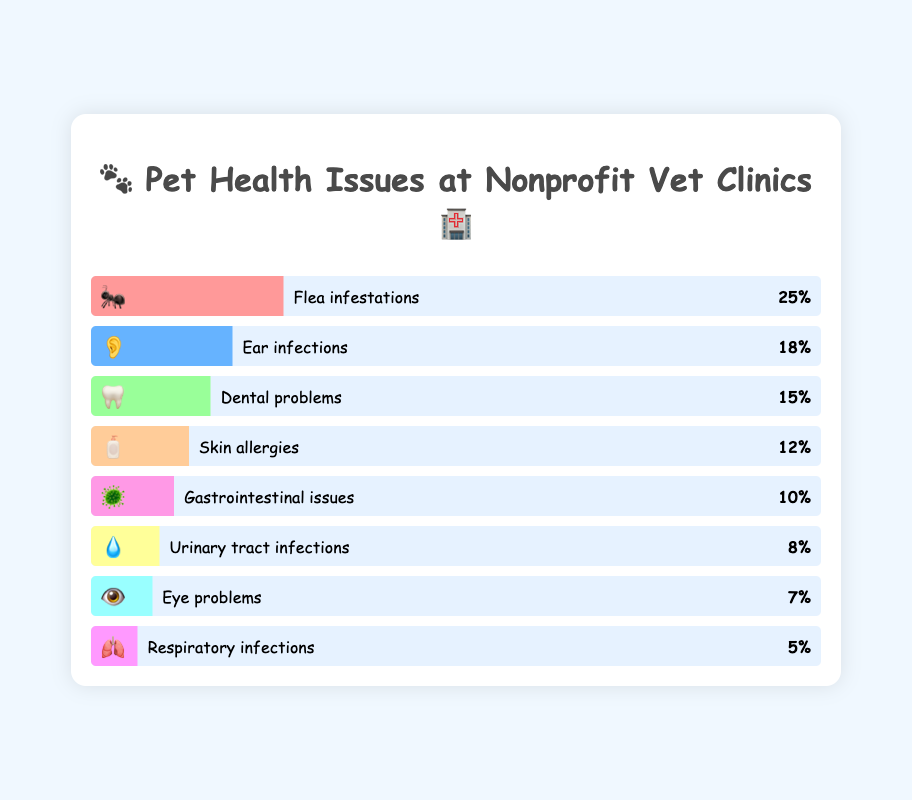What's the most common pet health issue treated at nonprofit veterinary clinics? The figure shows a bar chart with different health issues represented by percentages. The largest bar, representing the highest percentage, corresponds to flea infestations.
Answer: Flea infestations Which pet health issue has a higher percentage, dental problems or gastrointestinal issues? By comparing the lengths of the bars, the dental problems bar (15%) is longer than the gastrointestinal issues bar (10%).
Answer: Dental problems How much greater is the percentage of ear infections compared to urinary tract infections? Ear infections are at 18%, and urinary tract infections are at 8%. The difference is calculated by subtracting 8 from 18.
Answer: 10% What percentage of pet health issues are related to skin allergies and gastrointestinal issues combined? To find the combined percentage, add the percentages of skin allergies (12%) and gastrointestinal issues (10%).
Answer: 22% Which health issue has the smallest percentage, and what is that percentage? The shortest bar corresponds to respiratory infections, which is 5%.
Answer: Respiratory infections, 5% Compare the percentage of eye problems to the percentage of urinary tract infections. Which one is higher? The eye problems percentage is 7%, and the urinary tract infections percentage is 8%. Comparing these, urinary tract infections have a higher percentage.
Answer: Urinary tract infections What's the combined percentage of the three least common pet health issues? The least common issues are respiratory infections (5%), eye problems (7%), and urinary tract infections (8%). Adding these gives 5 + 7 + 8.
Answer: 20% How much lower is the percentage of skin allergies compared to flea infestations? The flea infestations percentage is 25%, and skin allergies are 12%. The difference is calculated by subtracting 12 from 25.
Answer: 13% Rank the top three pet health issues in terms of percentage. By examining the lengths of the bars and their percentages: flea infestations (25%), ear infections (18%), and dental problems (15%).
Answer: Flea infestations, ear infections, dental problems How much greater is the percentage of ear infections compared to skin allergies? Ear infections are at 18%, and skin allergies are at 12%. The difference is calculated by subtracting 12 from 18.
Answer: 6% 